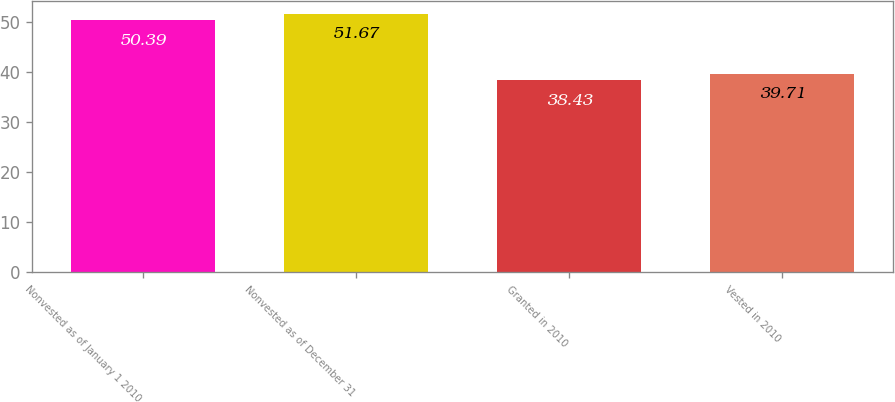<chart> <loc_0><loc_0><loc_500><loc_500><bar_chart><fcel>Nonvested as of January 1 2010<fcel>Nonvested as of December 31<fcel>Granted in 2010<fcel>Vested in 2010<nl><fcel>50.39<fcel>51.67<fcel>38.43<fcel>39.71<nl></chart> 